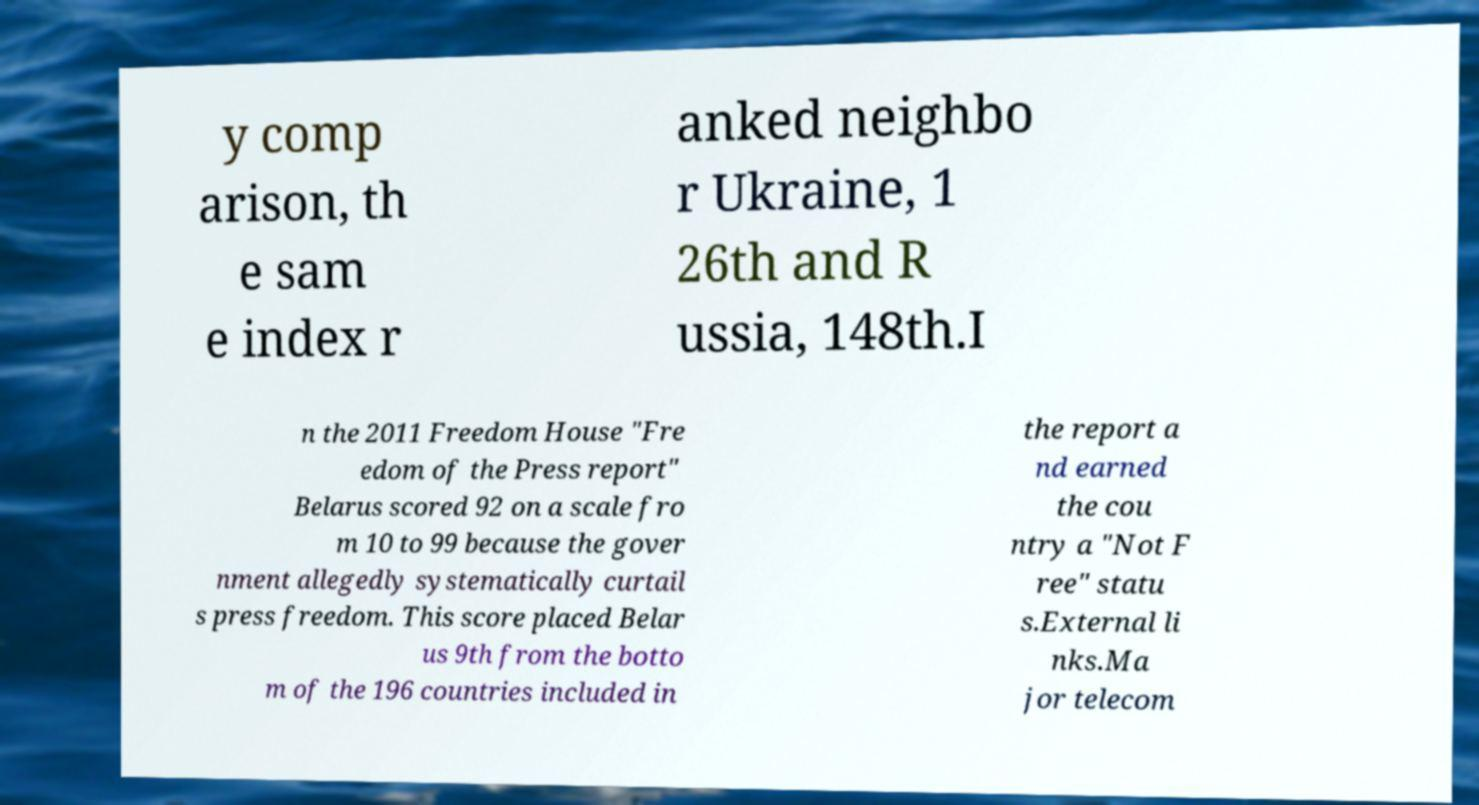Can you accurately transcribe the text from the provided image for me? y comp arison, th e sam e index r anked neighbo r Ukraine, 1 26th and R ussia, 148th.I n the 2011 Freedom House "Fre edom of the Press report" Belarus scored 92 on a scale fro m 10 to 99 because the gover nment allegedly systematically curtail s press freedom. This score placed Belar us 9th from the botto m of the 196 countries included in the report a nd earned the cou ntry a "Not F ree" statu s.External li nks.Ma jor telecom 